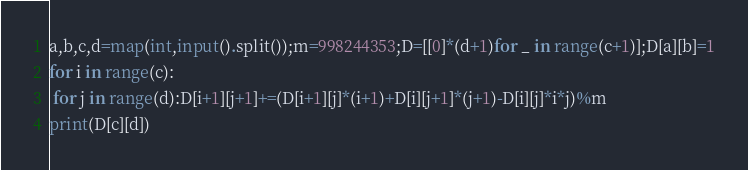<code> <loc_0><loc_0><loc_500><loc_500><_Python_>a,b,c,d=map(int,input().split());m=998244353;D=[[0]*(d+1)for _ in range(c+1)];D[a][b]=1
for i in range(c):
 for j in range(d):D[i+1][j+1]+=(D[i+1][j]*(i+1)+D[i][j+1]*(j+1)-D[i][j]*i*j)%m
print(D[c][d])</code> 